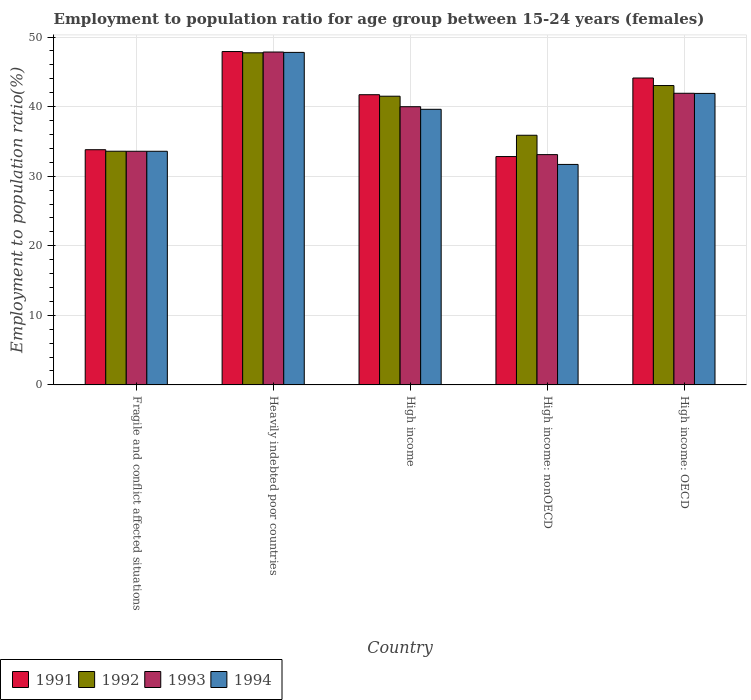How many different coloured bars are there?
Your answer should be very brief. 4. Are the number of bars per tick equal to the number of legend labels?
Give a very brief answer. Yes. What is the label of the 2nd group of bars from the left?
Provide a short and direct response. Heavily indebted poor countries. In how many cases, is the number of bars for a given country not equal to the number of legend labels?
Keep it short and to the point. 0. What is the employment to population ratio in 1991 in High income: OECD?
Give a very brief answer. 44.12. Across all countries, what is the maximum employment to population ratio in 1994?
Your answer should be compact. 47.8. Across all countries, what is the minimum employment to population ratio in 1991?
Your answer should be compact. 32.83. In which country was the employment to population ratio in 1992 maximum?
Ensure brevity in your answer.  Heavily indebted poor countries. In which country was the employment to population ratio in 1992 minimum?
Offer a terse response. Fragile and conflict affected situations. What is the total employment to population ratio in 1991 in the graph?
Provide a succinct answer. 200.39. What is the difference between the employment to population ratio in 1991 in High income and that in High income: nonOECD?
Your response must be concise. 8.89. What is the difference between the employment to population ratio in 1992 in Heavily indebted poor countries and the employment to population ratio in 1991 in High income: nonOECD?
Ensure brevity in your answer.  14.91. What is the average employment to population ratio in 1993 per country?
Offer a very short reply. 39.29. What is the difference between the employment to population ratio of/in 1991 and employment to population ratio of/in 1993 in High income: OECD?
Keep it short and to the point. 2.2. In how many countries, is the employment to population ratio in 1994 greater than 48 %?
Your answer should be compact. 0. What is the ratio of the employment to population ratio in 1994 in High income to that in High income: OECD?
Offer a terse response. 0.95. Is the employment to population ratio in 1993 in Heavily indebted poor countries less than that in High income: nonOECD?
Your answer should be very brief. No. Is the difference between the employment to population ratio in 1991 in Fragile and conflict affected situations and High income: OECD greater than the difference between the employment to population ratio in 1993 in Fragile and conflict affected situations and High income: OECD?
Offer a very short reply. No. What is the difference between the highest and the second highest employment to population ratio in 1994?
Ensure brevity in your answer.  2.28. What is the difference between the highest and the lowest employment to population ratio in 1992?
Your answer should be compact. 14.15. Is the sum of the employment to population ratio in 1993 in High income and High income: nonOECD greater than the maximum employment to population ratio in 1992 across all countries?
Your response must be concise. Yes. What does the 1st bar from the right in High income: nonOECD represents?
Make the answer very short. 1994. How many bars are there?
Provide a short and direct response. 20. Are all the bars in the graph horizontal?
Your response must be concise. No. Are the values on the major ticks of Y-axis written in scientific E-notation?
Your answer should be very brief. No. Does the graph contain any zero values?
Make the answer very short. No. How many legend labels are there?
Keep it short and to the point. 4. What is the title of the graph?
Make the answer very short. Employment to population ratio for age group between 15-24 years (females). What is the label or title of the X-axis?
Offer a terse response. Country. What is the label or title of the Y-axis?
Offer a very short reply. Employment to population ratio(%). What is the Employment to population ratio(%) in 1991 in Fragile and conflict affected situations?
Provide a short and direct response. 33.81. What is the Employment to population ratio(%) of 1992 in Fragile and conflict affected situations?
Your response must be concise. 33.59. What is the Employment to population ratio(%) of 1993 in Fragile and conflict affected situations?
Offer a very short reply. 33.59. What is the Employment to population ratio(%) in 1994 in Fragile and conflict affected situations?
Your answer should be very brief. 33.59. What is the Employment to population ratio(%) of 1991 in Heavily indebted poor countries?
Ensure brevity in your answer.  47.92. What is the Employment to population ratio(%) in 1992 in Heavily indebted poor countries?
Your answer should be compact. 47.74. What is the Employment to population ratio(%) of 1993 in Heavily indebted poor countries?
Your answer should be very brief. 47.85. What is the Employment to population ratio(%) of 1994 in Heavily indebted poor countries?
Offer a terse response. 47.8. What is the Employment to population ratio(%) in 1991 in High income?
Keep it short and to the point. 41.72. What is the Employment to population ratio(%) of 1992 in High income?
Your response must be concise. 41.5. What is the Employment to population ratio(%) of 1993 in High income?
Provide a succinct answer. 39.99. What is the Employment to population ratio(%) in 1994 in High income?
Ensure brevity in your answer.  39.62. What is the Employment to population ratio(%) of 1991 in High income: nonOECD?
Ensure brevity in your answer.  32.83. What is the Employment to population ratio(%) of 1992 in High income: nonOECD?
Keep it short and to the point. 35.89. What is the Employment to population ratio(%) of 1993 in High income: nonOECD?
Offer a very short reply. 33.1. What is the Employment to population ratio(%) in 1994 in High income: nonOECD?
Keep it short and to the point. 31.69. What is the Employment to population ratio(%) in 1991 in High income: OECD?
Keep it short and to the point. 44.12. What is the Employment to population ratio(%) of 1992 in High income: OECD?
Give a very brief answer. 43.03. What is the Employment to population ratio(%) of 1993 in High income: OECD?
Ensure brevity in your answer.  41.92. What is the Employment to population ratio(%) of 1994 in High income: OECD?
Provide a short and direct response. 41.9. Across all countries, what is the maximum Employment to population ratio(%) of 1991?
Offer a terse response. 47.92. Across all countries, what is the maximum Employment to population ratio(%) in 1992?
Provide a short and direct response. 47.74. Across all countries, what is the maximum Employment to population ratio(%) of 1993?
Offer a terse response. 47.85. Across all countries, what is the maximum Employment to population ratio(%) of 1994?
Your response must be concise. 47.8. Across all countries, what is the minimum Employment to population ratio(%) of 1991?
Your response must be concise. 32.83. Across all countries, what is the minimum Employment to population ratio(%) of 1992?
Provide a short and direct response. 33.59. Across all countries, what is the minimum Employment to population ratio(%) of 1993?
Provide a succinct answer. 33.1. Across all countries, what is the minimum Employment to population ratio(%) in 1994?
Your response must be concise. 31.69. What is the total Employment to population ratio(%) in 1991 in the graph?
Give a very brief answer. 200.39. What is the total Employment to population ratio(%) in 1992 in the graph?
Make the answer very short. 201.75. What is the total Employment to population ratio(%) in 1993 in the graph?
Your response must be concise. 196.45. What is the total Employment to population ratio(%) of 1994 in the graph?
Offer a very short reply. 194.6. What is the difference between the Employment to population ratio(%) of 1991 in Fragile and conflict affected situations and that in Heavily indebted poor countries?
Offer a very short reply. -14.11. What is the difference between the Employment to population ratio(%) of 1992 in Fragile and conflict affected situations and that in Heavily indebted poor countries?
Ensure brevity in your answer.  -14.15. What is the difference between the Employment to population ratio(%) of 1993 in Fragile and conflict affected situations and that in Heavily indebted poor countries?
Your answer should be very brief. -14.26. What is the difference between the Employment to population ratio(%) of 1994 in Fragile and conflict affected situations and that in Heavily indebted poor countries?
Your response must be concise. -14.21. What is the difference between the Employment to population ratio(%) of 1991 in Fragile and conflict affected situations and that in High income?
Offer a terse response. -7.91. What is the difference between the Employment to population ratio(%) of 1992 in Fragile and conflict affected situations and that in High income?
Provide a succinct answer. -7.91. What is the difference between the Employment to population ratio(%) of 1993 in Fragile and conflict affected situations and that in High income?
Give a very brief answer. -6.4. What is the difference between the Employment to population ratio(%) in 1994 in Fragile and conflict affected situations and that in High income?
Make the answer very short. -6.03. What is the difference between the Employment to population ratio(%) in 1991 in Fragile and conflict affected situations and that in High income: nonOECD?
Make the answer very short. 0.98. What is the difference between the Employment to population ratio(%) in 1992 in Fragile and conflict affected situations and that in High income: nonOECD?
Provide a short and direct response. -2.3. What is the difference between the Employment to population ratio(%) of 1993 in Fragile and conflict affected situations and that in High income: nonOECD?
Offer a terse response. 0.48. What is the difference between the Employment to population ratio(%) in 1994 in Fragile and conflict affected situations and that in High income: nonOECD?
Offer a terse response. 1.89. What is the difference between the Employment to population ratio(%) of 1991 in Fragile and conflict affected situations and that in High income: OECD?
Provide a succinct answer. -10.31. What is the difference between the Employment to population ratio(%) in 1992 in Fragile and conflict affected situations and that in High income: OECD?
Ensure brevity in your answer.  -9.44. What is the difference between the Employment to population ratio(%) in 1993 in Fragile and conflict affected situations and that in High income: OECD?
Provide a succinct answer. -8.33. What is the difference between the Employment to population ratio(%) in 1994 in Fragile and conflict affected situations and that in High income: OECD?
Make the answer very short. -8.32. What is the difference between the Employment to population ratio(%) in 1991 in Heavily indebted poor countries and that in High income?
Make the answer very short. 6.2. What is the difference between the Employment to population ratio(%) in 1992 in Heavily indebted poor countries and that in High income?
Your answer should be compact. 6.24. What is the difference between the Employment to population ratio(%) in 1993 in Heavily indebted poor countries and that in High income?
Your answer should be compact. 7.86. What is the difference between the Employment to population ratio(%) of 1994 in Heavily indebted poor countries and that in High income?
Make the answer very short. 8.18. What is the difference between the Employment to population ratio(%) in 1991 in Heavily indebted poor countries and that in High income: nonOECD?
Give a very brief answer. 15.1. What is the difference between the Employment to population ratio(%) in 1992 in Heavily indebted poor countries and that in High income: nonOECD?
Ensure brevity in your answer.  11.85. What is the difference between the Employment to population ratio(%) in 1993 in Heavily indebted poor countries and that in High income: nonOECD?
Make the answer very short. 14.75. What is the difference between the Employment to population ratio(%) in 1994 in Heavily indebted poor countries and that in High income: nonOECD?
Provide a short and direct response. 16.1. What is the difference between the Employment to population ratio(%) of 1991 in Heavily indebted poor countries and that in High income: OECD?
Provide a succinct answer. 3.8. What is the difference between the Employment to population ratio(%) of 1992 in Heavily indebted poor countries and that in High income: OECD?
Make the answer very short. 4.71. What is the difference between the Employment to population ratio(%) in 1993 in Heavily indebted poor countries and that in High income: OECD?
Ensure brevity in your answer.  5.93. What is the difference between the Employment to population ratio(%) in 1994 in Heavily indebted poor countries and that in High income: OECD?
Your answer should be compact. 5.89. What is the difference between the Employment to population ratio(%) in 1991 in High income and that in High income: nonOECD?
Provide a succinct answer. 8.89. What is the difference between the Employment to population ratio(%) of 1992 in High income and that in High income: nonOECD?
Your answer should be compact. 5.61. What is the difference between the Employment to population ratio(%) in 1993 in High income and that in High income: nonOECD?
Offer a terse response. 6.89. What is the difference between the Employment to population ratio(%) of 1994 in High income and that in High income: nonOECD?
Keep it short and to the point. 7.92. What is the difference between the Employment to population ratio(%) in 1991 in High income and that in High income: OECD?
Provide a succinct answer. -2.4. What is the difference between the Employment to population ratio(%) in 1992 in High income and that in High income: OECD?
Offer a very short reply. -1.53. What is the difference between the Employment to population ratio(%) of 1993 in High income and that in High income: OECD?
Keep it short and to the point. -1.93. What is the difference between the Employment to population ratio(%) of 1994 in High income and that in High income: OECD?
Your response must be concise. -2.28. What is the difference between the Employment to population ratio(%) of 1991 in High income: nonOECD and that in High income: OECD?
Provide a short and direct response. -11.29. What is the difference between the Employment to population ratio(%) of 1992 in High income: nonOECD and that in High income: OECD?
Ensure brevity in your answer.  -7.15. What is the difference between the Employment to population ratio(%) in 1993 in High income: nonOECD and that in High income: OECD?
Provide a short and direct response. -8.82. What is the difference between the Employment to population ratio(%) in 1994 in High income: nonOECD and that in High income: OECD?
Your response must be concise. -10.21. What is the difference between the Employment to population ratio(%) in 1991 in Fragile and conflict affected situations and the Employment to population ratio(%) in 1992 in Heavily indebted poor countries?
Your answer should be compact. -13.93. What is the difference between the Employment to population ratio(%) of 1991 in Fragile and conflict affected situations and the Employment to population ratio(%) of 1993 in Heavily indebted poor countries?
Ensure brevity in your answer.  -14.04. What is the difference between the Employment to population ratio(%) of 1991 in Fragile and conflict affected situations and the Employment to population ratio(%) of 1994 in Heavily indebted poor countries?
Offer a very short reply. -13.99. What is the difference between the Employment to population ratio(%) of 1992 in Fragile and conflict affected situations and the Employment to population ratio(%) of 1993 in Heavily indebted poor countries?
Your answer should be very brief. -14.26. What is the difference between the Employment to population ratio(%) of 1992 in Fragile and conflict affected situations and the Employment to population ratio(%) of 1994 in Heavily indebted poor countries?
Ensure brevity in your answer.  -14.21. What is the difference between the Employment to population ratio(%) in 1993 in Fragile and conflict affected situations and the Employment to population ratio(%) in 1994 in Heavily indebted poor countries?
Make the answer very short. -14.21. What is the difference between the Employment to population ratio(%) of 1991 in Fragile and conflict affected situations and the Employment to population ratio(%) of 1992 in High income?
Provide a short and direct response. -7.69. What is the difference between the Employment to population ratio(%) of 1991 in Fragile and conflict affected situations and the Employment to population ratio(%) of 1993 in High income?
Your answer should be compact. -6.18. What is the difference between the Employment to population ratio(%) of 1991 in Fragile and conflict affected situations and the Employment to population ratio(%) of 1994 in High income?
Your response must be concise. -5.81. What is the difference between the Employment to population ratio(%) of 1992 in Fragile and conflict affected situations and the Employment to population ratio(%) of 1993 in High income?
Provide a short and direct response. -6.4. What is the difference between the Employment to population ratio(%) of 1992 in Fragile and conflict affected situations and the Employment to population ratio(%) of 1994 in High income?
Keep it short and to the point. -6.03. What is the difference between the Employment to population ratio(%) of 1993 in Fragile and conflict affected situations and the Employment to population ratio(%) of 1994 in High income?
Make the answer very short. -6.03. What is the difference between the Employment to population ratio(%) in 1991 in Fragile and conflict affected situations and the Employment to population ratio(%) in 1992 in High income: nonOECD?
Offer a very short reply. -2.08. What is the difference between the Employment to population ratio(%) in 1991 in Fragile and conflict affected situations and the Employment to population ratio(%) in 1993 in High income: nonOECD?
Ensure brevity in your answer.  0.71. What is the difference between the Employment to population ratio(%) of 1991 in Fragile and conflict affected situations and the Employment to population ratio(%) of 1994 in High income: nonOECD?
Your response must be concise. 2.12. What is the difference between the Employment to population ratio(%) in 1992 in Fragile and conflict affected situations and the Employment to population ratio(%) in 1993 in High income: nonOECD?
Provide a short and direct response. 0.49. What is the difference between the Employment to population ratio(%) in 1992 in Fragile and conflict affected situations and the Employment to population ratio(%) in 1994 in High income: nonOECD?
Your response must be concise. 1.9. What is the difference between the Employment to population ratio(%) in 1993 in Fragile and conflict affected situations and the Employment to population ratio(%) in 1994 in High income: nonOECD?
Make the answer very short. 1.89. What is the difference between the Employment to population ratio(%) of 1991 in Fragile and conflict affected situations and the Employment to population ratio(%) of 1992 in High income: OECD?
Your response must be concise. -9.22. What is the difference between the Employment to population ratio(%) in 1991 in Fragile and conflict affected situations and the Employment to population ratio(%) in 1993 in High income: OECD?
Offer a terse response. -8.11. What is the difference between the Employment to population ratio(%) in 1991 in Fragile and conflict affected situations and the Employment to population ratio(%) in 1994 in High income: OECD?
Give a very brief answer. -8.09. What is the difference between the Employment to population ratio(%) of 1992 in Fragile and conflict affected situations and the Employment to population ratio(%) of 1993 in High income: OECD?
Provide a succinct answer. -8.33. What is the difference between the Employment to population ratio(%) in 1992 in Fragile and conflict affected situations and the Employment to population ratio(%) in 1994 in High income: OECD?
Provide a succinct answer. -8.31. What is the difference between the Employment to population ratio(%) of 1993 in Fragile and conflict affected situations and the Employment to population ratio(%) of 1994 in High income: OECD?
Ensure brevity in your answer.  -8.31. What is the difference between the Employment to population ratio(%) of 1991 in Heavily indebted poor countries and the Employment to population ratio(%) of 1992 in High income?
Offer a terse response. 6.42. What is the difference between the Employment to population ratio(%) in 1991 in Heavily indebted poor countries and the Employment to population ratio(%) in 1993 in High income?
Provide a succinct answer. 7.93. What is the difference between the Employment to population ratio(%) in 1991 in Heavily indebted poor countries and the Employment to population ratio(%) in 1994 in High income?
Your answer should be compact. 8.3. What is the difference between the Employment to population ratio(%) of 1992 in Heavily indebted poor countries and the Employment to population ratio(%) of 1993 in High income?
Give a very brief answer. 7.75. What is the difference between the Employment to population ratio(%) of 1992 in Heavily indebted poor countries and the Employment to population ratio(%) of 1994 in High income?
Your answer should be very brief. 8.12. What is the difference between the Employment to population ratio(%) in 1993 in Heavily indebted poor countries and the Employment to population ratio(%) in 1994 in High income?
Offer a very short reply. 8.23. What is the difference between the Employment to population ratio(%) in 1991 in Heavily indebted poor countries and the Employment to population ratio(%) in 1992 in High income: nonOECD?
Your response must be concise. 12.03. What is the difference between the Employment to population ratio(%) in 1991 in Heavily indebted poor countries and the Employment to population ratio(%) in 1993 in High income: nonOECD?
Provide a short and direct response. 14.82. What is the difference between the Employment to population ratio(%) of 1991 in Heavily indebted poor countries and the Employment to population ratio(%) of 1994 in High income: nonOECD?
Your answer should be very brief. 16.23. What is the difference between the Employment to population ratio(%) of 1992 in Heavily indebted poor countries and the Employment to population ratio(%) of 1993 in High income: nonOECD?
Offer a terse response. 14.64. What is the difference between the Employment to population ratio(%) of 1992 in Heavily indebted poor countries and the Employment to population ratio(%) of 1994 in High income: nonOECD?
Offer a very short reply. 16.05. What is the difference between the Employment to population ratio(%) of 1993 in Heavily indebted poor countries and the Employment to population ratio(%) of 1994 in High income: nonOECD?
Make the answer very short. 16.16. What is the difference between the Employment to population ratio(%) in 1991 in Heavily indebted poor countries and the Employment to population ratio(%) in 1992 in High income: OECD?
Keep it short and to the point. 4.89. What is the difference between the Employment to population ratio(%) in 1991 in Heavily indebted poor countries and the Employment to population ratio(%) in 1993 in High income: OECD?
Provide a succinct answer. 6. What is the difference between the Employment to population ratio(%) of 1991 in Heavily indebted poor countries and the Employment to population ratio(%) of 1994 in High income: OECD?
Provide a short and direct response. 6.02. What is the difference between the Employment to population ratio(%) in 1992 in Heavily indebted poor countries and the Employment to population ratio(%) in 1993 in High income: OECD?
Offer a very short reply. 5.82. What is the difference between the Employment to population ratio(%) in 1992 in Heavily indebted poor countries and the Employment to population ratio(%) in 1994 in High income: OECD?
Provide a short and direct response. 5.84. What is the difference between the Employment to population ratio(%) in 1993 in Heavily indebted poor countries and the Employment to population ratio(%) in 1994 in High income: OECD?
Make the answer very short. 5.95. What is the difference between the Employment to population ratio(%) in 1991 in High income and the Employment to population ratio(%) in 1992 in High income: nonOECD?
Offer a very short reply. 5.83. What is the difference between the Employment to population ratio(%) in 1991 in High income and the Employment to population ratio(%) in 1993 in High income: nonOECD?
Your response must be concise. 8.61. What is the difference between the Employment to population ratio(%) in 1991 in High income and the Employment to population ratio(%) in 1994 in High income: nonOECD?
Offer a very short reply. 10.02. What is the difference between the Employment to population ratio(%) in 1992 in High income and the Employment to population ratio(%) in 1993 in High income: nonOECD?
Offer a terse response. 8.4. What is the difference between the Employment to population ratio(%) in 1992 in High income and the Employment to population ratio(%) in 1994 in High income: nonOECD?
Offer a terse response. 9.81. What is the difference between the Employment to population ratio(%) in 1993 in High income and the Employment to population ratio(%) in 1994 in High income: nonOECD?
Your answer should be compact. 8.3. What is the difference between the Employment to population ratio(%) of 1991 in High income and the Employment to population ratio(%) of 1992 in High income: OECD?
Your answer should be very brief. -1.32. What is the difference between the Employment to population ratio(%) of 1991 in High income and the Employment to population ratio(%) of 1993 in High income: OECD?
Your response must be concise. -0.21. What is the difference between the Employment to population ratio(%) in 1991 in High income and the Employment to population ratio(%) in 1994 in High income: OECD?
Provide a succinct answer. -0.19. What is the difference between the Employment to population ratio(%) in 1992 in High income and the Employment to population ratio(%) in 1993 in High income: OECD?
Offer a terse response. -0.42. What is the difference between the Employment to population ratio(%) in 1992 in High income and the Employment to population ratio(%) in 1994 in High income: OECD?
Make the answer very short. -0.4. What is the difference between the Employment to population ratio(%) of 1993 in High income and the Employment to population ratio(%) of 1994 in High income: OECD?
Make the answer very short. -1.91. What is the difference between the Employment to population ratio(%) in 1991 in High income: nonOECD and the Employment to population ratio(%) in 1992 in High income: OECD?
Your answer should be very brief. -10.21. What is the difference between the Employment to population ratio(%) of 1991 in High income: nonOECD and the Employment to population ratio(%) of 1993 in High income: OECD?
Give a very brief answer. -9.1. What is the difference between the Employment to population ratio(%) of 1991 in High income: nonOECD and the Employment to population ratio(%) of 1994 in High income: OECD?
Offer a terse response. -9.08. What is the difference between the Employment to population ratio(%) of 1992 in High income: nonOECD and the Employment to population ratio(%) of 1993 in High income: OECD?
Give a very brief answer. -6.04. What is the difference between the Employment to population ratio(%) in 1992 in High income: nonOECD and the Employment to population ratio(%) in 1994 in High income: OECD?
Provide a succinct answer. -6.02. What is the difference between the Employment to population ratio(%) of 1993 in High income: nonOECD and the Employment to population ratio(%) of 1994 in High income: OECD?
Keep it short and to the point. -8.8. What is the average Employment to population ratio(%) of 1991 per country?
Make the answer very short. 40.08. What is the average Employment to population ratio(%) in 1992 per country?
Provide a short and direct response. 40.35. What is the average Employment to population ratio(%) in 1993 per country?
Your answer should be very brief. 39.29. What is the average Employment to population ratio(%) in 1994 per country?
Make the answer very short. 38.92. What is the difference between the Employment to population ratio(%) of 1991 and Employment to population ratio(%) of 1992 in Fragile and conflict affected situations?
Provide a short and direct response. 0.22. What is the difference between the Employment to population ratio(%) of 1991 and Employment to population ratio(%) of 1993 in Fragile and conflict affected situations?
Offer a very short reply. 0.22. What is the difference between the Employment to population ratio(%) in 1991 and Employment to population ratio(%) in 1994 in Fragile and conflict affected situations?
Your answer should be compact. 0.22. What is the difference between the Employment to population ratio(%) of 1992 and Employment to population ratio(%) of 1993 in Fragile and conflict affected situations?
Provide a short and direct response. 0. What is the difference between the Employment to population ratio(%) in 1992 and Employment to population ratio(%) in 1994 in Fragile and conflict affected situations?
Your answer should be very brief. 0.01. What is the difference between the Employment to population ratio(%) of 1993 and Employment to population ratio(%) of 1994 in Fragile and conflict affected situations?
Keep it short and to the point. 0. What is the difference between the Employment to population ratio(%) in 1991 and Employment to population ratio(%) in 1992 in Heavily indebted poor countries?
Keep it short and to the point. 0.18. What is the difference between the Employment to population ratio(%) of 1991 and Employment to population ratio(%) of 1993 in Heavily indebted poor countries?
Make the answer very short. 0.07. What is the difference between the Employment to population ratio(%) in 1991 and Employment to population ratio(%) in 1994 in Heavily indebted poor countries?
Give a very brief answer. 0.12. What is the difference between the Employment to population ratio(%) of 1992 and Employment to population ratio(%) of 1993 in Heavily indebted poor countries?
Offer a very short reply. -0.11. What is the difference between the Employment to population ratio(%) of 1992 and Employment to population ratio(%) of 1994 in Heavily indebted poor countries?
Provide a short and direct response. -0.06. What is the difference between the Employment to population ratio(%) in 1993 and Employment to population ratio(%) in 1994 in Heavily indebted poor countries?
Your answer should be very brief. 0.05. What is the difference between the Employment to population ratio(%) in 1991 and Employment to population ratio(%) in 1992 in High income?
Offer a very short reply. 0.22. What is the difference between the Employment to population ratio(%) in 1991 and Employment to population ratio(%) in 1993 in High income?
Your answer should be very brief. 1.72. What is the difference between the Employment to population ratio(%) of 1991 and Employment to population ratio(%) of 1994 in High income?
Your answer should be very brief. 2.1. What is the difference between the Employment to population ratio(%) in 1992 and Employment to population ratio(%) in 1993 in High income?
Offer a terse response. 1.51. What is the difference between the Employment to population ratio(%) in 1992 and Employment to population ratio(%) in 1994 in High income?
Your answer should be very brief. 1.88. What is the difference between the Employment to population ratio(%) in 1993 and Employment to population ratio(%) in 1994 in High income?
Keep it short and to the point. 0.37. What is the difference between the Employment to population ratio(%) of 1991 and Employment to population ratio(%) of 1992 in High income: nonOECD?
Make the answer very short. -3.06. What is the difference between the Employment to population ratio(%) of 1991 and Employment to population ratio(%) of 1993 in High income: nonOECD?
Provide a short and direct response. -0.28. What is the difference between the Employment to population ratio(%) of 1991 and Employment to population ratio(%) of 1994 in High income: nonOECD?
Provide a succinct answer. 1.13. What is the difference between the Employment to population ratio(%) of 1992 and Employment to population ratio(%) of 1993 in High income: nonOECD?
Offer a very short reply. 2.78. What is the difference between the Employment to population ratio(%) in 1992 and Employment to population ratio(%) in 1994 in High income: nonOECD?
Ensure brevity in your answer.  4.19. What is the difference between the Employment to population ratio(%) in 1993 and Employment to population ratio(%) in 1994 in High income: nonOECD?
Offer a terse response. 1.41. What is the difference between the Employment to population ratio(%) of 1991 and Employment to population ratio(%) of 1992 in High income: OECD?
Offer a terse response. 1.08. What is the difference between the Employment to population ratio(%) of 1991 and Employment to population ratio(%) of 1993 in High income: OECD?
Offer a very short reply. 2.2. What is the difference between the Employment to population ratio(%) in 1991 and Employment to population ratio(%) in 1994 in High income: OECD?
Give a very brief answer. 2.21. What is the difference between the Employment to population ratio(%) of 1992 and Employment to population ratio(%) of 1993 in High income: OECD?
Keep it short and to the point. 1.11. What is the difference between the Employment to population ratio(%) of 1992 and Employment to population ratio(%) of 1994 in High income: OECD?
Provide a succinct answer. 1.13. What is the difference between the Employment to population ratio(%) in 1993 and Employment to population ratio(%) in 1994 in High income: OECD?
Offer a very short reply. 0.02. What is the ratio of the Employment to population ratio(%) in 1991 in Fragile and conflict affected situations to that in Heavily indebted poor countries?
Provide a short and direct response. 0.71. What is the ratio of the Employment to population ratio(%) of 1992 in Fragile and conflict affected situations to that in Heavily indebted poor countries?
Provide a succinct answer. 0.7. What is the ratio of the Employment to population ratio(%) of 1993 in Fragile and conflict affected situations to that in Heavily indebted poor countries?
Provide a short and direct response. 0.7. What is the ratio of the Employment to population ratio(%) of 1994 in Fragile and conflict affected situations to that in Heavily indebted poor countries?
Keep it short and to the point. 0.7. What is the ratio of the Employment to population ratio(%) in 1991 in Fragile and conflict affected situations to that in High income?
Ensure brevity in your answer.  0.81. What is the ratio of the Employment to population ratio(%) in 1992 in Fragile and conflict affected situations to that in High income?
Your answer should be very brief. 0.81. What is the ratio of the Employment to population ratio(%) in 1993 in Fragile and conflict affected situations to that in High income?
Ensure brevity in your answer.  0.84. What is the ratio of the Employment to population ratio(%) in 1994 in Fragile and conflict affected situations to that in High income?
Give a very brief answer. 0.85. What is the ratio of the Employment to population ratio(%) in 1992 in Fragile and conflict affected situations to that in High income: nonOECD?
Offer a terse response. 0.94. What is the ratio of the Employment to population ratio(%) of 1993 in Fragile and conflict affected situations to that in High income: nonOECD?
Your answer should be compact. 1.01. What is the ratio of the Employment to population ratio(%) in 1994 in Fragile and conflict affected situations to that in High income: nonOECD?
Provide a succinct answer. 1.06. What is the ratio of the Employment to population ratio(%) in 1991 in Fragile and conflict affected situations to that in High income: OECD?
Offer a terse response. 0.77. What is the ratio of the Employment to population ratio(%) of 1992 in Fragile and conflict affected situations to that in High income: OECD?
Provide a short and direct response. 0.78. What is the ratio of the Employment to population ratio(%) in 1993 in Fragile and conflict affected situations to that in High income: OECD?
Provide a short and direct response. 0.8. What is the ratio of the Employment to population ratio(%) of 1994 in Fragile and conflict affected situations to that in High income: OECD?
Keep it short and to the point. 0.8. What is the ratio of the Employment to population ratio(%) of 1991 in Heavily indebted poor countries to that in High income?
Your response must be concise. 1.15. What is the ratio of the Employment to population ratio(%) in 1992 in Heavily indebted poor countries to that in High income?
Keep it short and to the point. 1.15. What is the ratio of the Employment to population ratio(%) of 1993 in Heavily indebted poor countries to that in High income?
Provide a short and direct response. 1.2. What is the ratio of the Employment to population ratio(%) in 1994 in Heavily indebted poor countries to that in High income?
Offer a very short reply. 1.21. What is the ratio of the Employment to population ratio(%) in 1991 in Heavily indebted poor countries to that in High income: nonOECD?
Make the answer very short. 1.46. What is the ratio of the Employment to population ratio(%) in 1992 in Heavily indebted poor countries to that in High income: nonOECD?
Your answer should be compact. 1.33. What is the ratio of the Employment to population ratio(%) of 1993 in Heavily indebted poor countries to that in High income: nonOECD?
Your response must be concise. 1.45. What is the ratio of the Employment to population ratio(%) in 1994 in Heavily indebted poor countries to that in High income: nonOECD?
Keep it short and to the point. 1.51. What is the ratio of the Employment to population ratio(%) of 1991 in Heavily indebted poor countries to that in High income: OECD?
Offer a very short reply. 1.09. What is the ratio of the Employment to population ratio(%) in 1992 in Heavily indebted poor countries to that in High income: OECD?
Your answer should be compact. 1.11. What is the ratio of the Employment to population ratio(%) of 1993 in Heavily indebted poor countries to that in High income: OECD?
Offer a terse response. 1.14. What is the ratio of the Employment to population ratio(%) of 1994 in Heavily indebted poor countries to that in High income: OECD?
Offer a very short reply. 1.14. What is the ratio of the Employment to population ratio(%) in 1991 in High income to that in High income: nonOECD?
Offer a terse response. 1.27. What is the ratio of the Employment to population ratio(%) of 1992 in High income to that in High income: nonOECD?
Offer a very short reply. 1.16. What is the ratio of the Employment to population ratio(%) in 1993 in High income to that in High income: nonOECD?
Ensure brevity in your answer.  1.21. What is the ratio of the Employment to population ratio(%) of 1994 in High income to that in High income: nonOECD?
Make the answer very short. 1.25. What is the ratio of the Employment to population ratio(%) in 1991 in High income to that in High income: OECD?
Make the answer very short. 0.95. What is the ratio of the Employment to population ratio(%) in 1992 in High income to that in High income: OECD?
Provide a succinct answer. 0.96. What is the ratio of the Employment to population ratio(%) in 1993 in High income to that in High income: OECD?
Your answer should be very brief. 0.95. What is the ratio of the Employment to population ratio(%) of 1994 in High income to that in High income: OECD?
Keep it short and to the point. 0.95. What is the ratio of the Employment to population ratio(%) in 1991 in High income: nonOECD to that in High income: OECD?
Ensure brevity in your answer.  0.74. What is the ratio of the Employment to population ratio(%) in 1992 in High income: nonOECD to that in High income: OECD?
Provide a short and direct response. 0.83. What is the ratio of the Employment to population ratio(%) of 1993 in High income: nonOECD to that in High income: OECD?
Give a very brief answer. 0.79. What is the ratio of the Employment to population ratio(%) in 1994 in High income: nonOECD to that in High income: OECD?
Keep it short and to the point. 0.76. What is the difference between the highest and the second highest Employment to population ratio(%) of 1991?
Your response must be concise. 3.8. What is the difference between the highest and the second highest Employment to population ratio(%) in 1992?
Your answer should be very brief. 4.71. What is the difference between the highest and the second highest Employment to population ratio(%) of 1993?
Provide a succinct answer. 5.93. What is the difference between the highest and the second highest Employment to population ratio(%) of 1994?
Provide a succinct answer. 5.89. What is the difference between the highest and the lowest Employment to population ratio(%) of 1991?
Make the answer very short. 15.1. What is the difference between the highest and the lowest Employment to population ratio(%) in 1992?
Offer a terse response. 14.15. What is the difference between the highest and the lowest Employment to population ratio(%) in 1993?
Provide a succinct answer. 14.75. What is the difference between the highest and the lowest Employment to population ratio(%) of 1994?
Offer a very short reply. 16.1. 